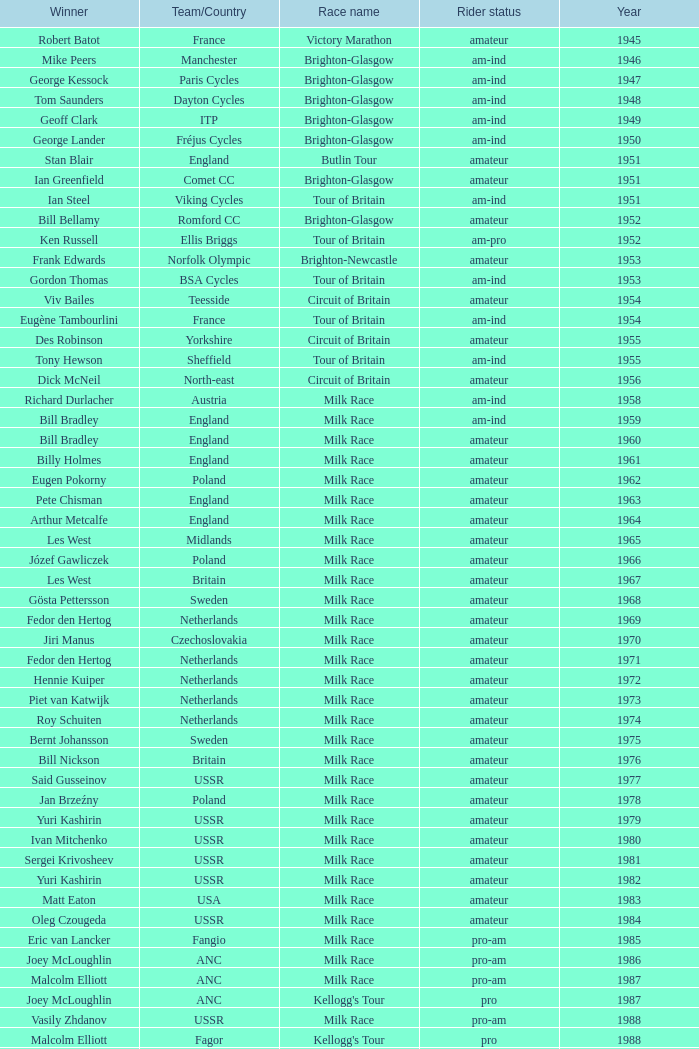What ream played later than 1958 in the kellogg's tour? ANC, Fagor, Z-Peugeot, Weinnmann-SMM, Motorola, Motorola, Motorola, Lampre. 